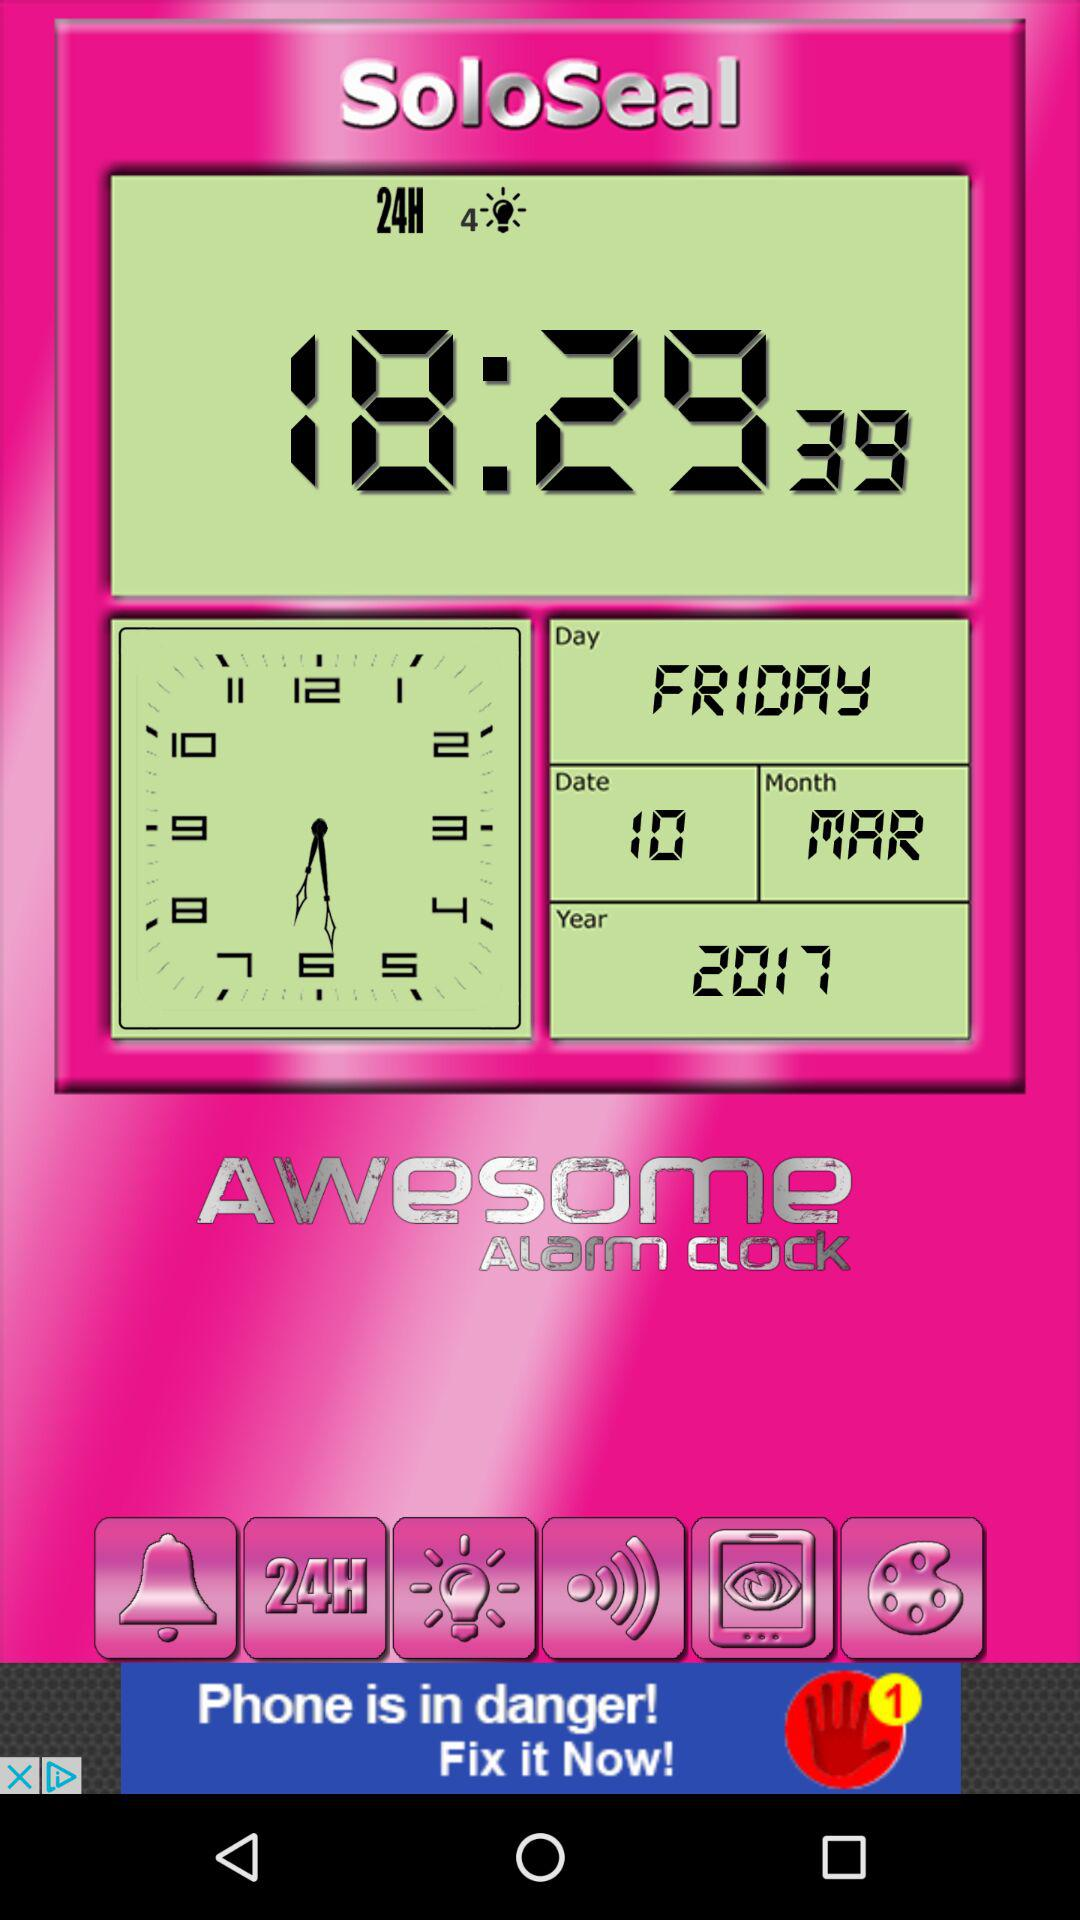What is the time? The time is 18:29:39. 